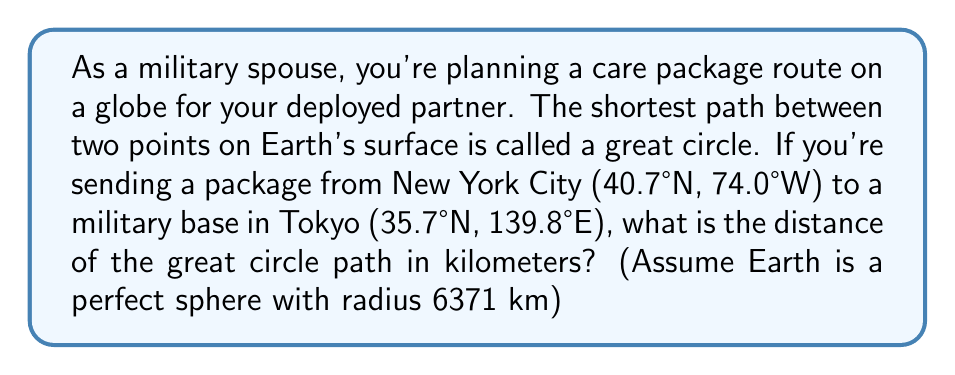Show me your answer to this math problem. To find the shortest path (great circle distance) between two points on a sphere, we can use the Haversine formula:

1) First, convert the latitudes and longitudes to radians:
   $$\begin{align}
   \text{lat}_1 &= 40.7° \times \frac{\pi}{180} = 0.7101 \text{ rad} \\
   \text{lon}_1 &= -74.0° \times \frac{\pi}{180} = -1.2915 \text{ rad} \\
   \text{lat}_2 &= 35.7° \times \frac{\pi}{180} = 0.6230 \text{ rad} \\
   \text{lon}_2 &= 139.8° \times \frac{\pi}{180} = 2.4400 \text{ rad}
   \end{align}$$

2) Calculate the difference in longitude:
   $$\Delta \text{lon} = \text{lon}_2 - \text{lon}_1 = 2.4400 - (-1.2915) = 3.7315 \text{ rad}$$

3) Apply the Haversine formula:
   $$a = \sin^2(\frac{\Delta \text{lat}}{2}) + \cos(\text{lat}_1) \cos(\text{lat}_2) \sin^2(\frac{\Delta \text{lon}}{2})$$
   
   $$a = \sin^2(\frac{0.6230 - 0.7101}{2}) + \cos(0.7101) \cos(0.6230) \sin^2(\frac{3.7315}{2}) = 0.6687$$

4) Calculate the central angle:
   $$c = 2 \arcsin(\sqrt{a}) = 2 \arcsin(\sqrt{0.6687}) = 1.8365 \text{ rad}$$

5) Compute the great circle distance:
   $$d = R \times c = 6371 \text{ km} \times 1.8365 = 11699.8 \text{ km}$$

Therefore, the shortest path distance is approximately 11,700 km.
Answer: 11,700 km 